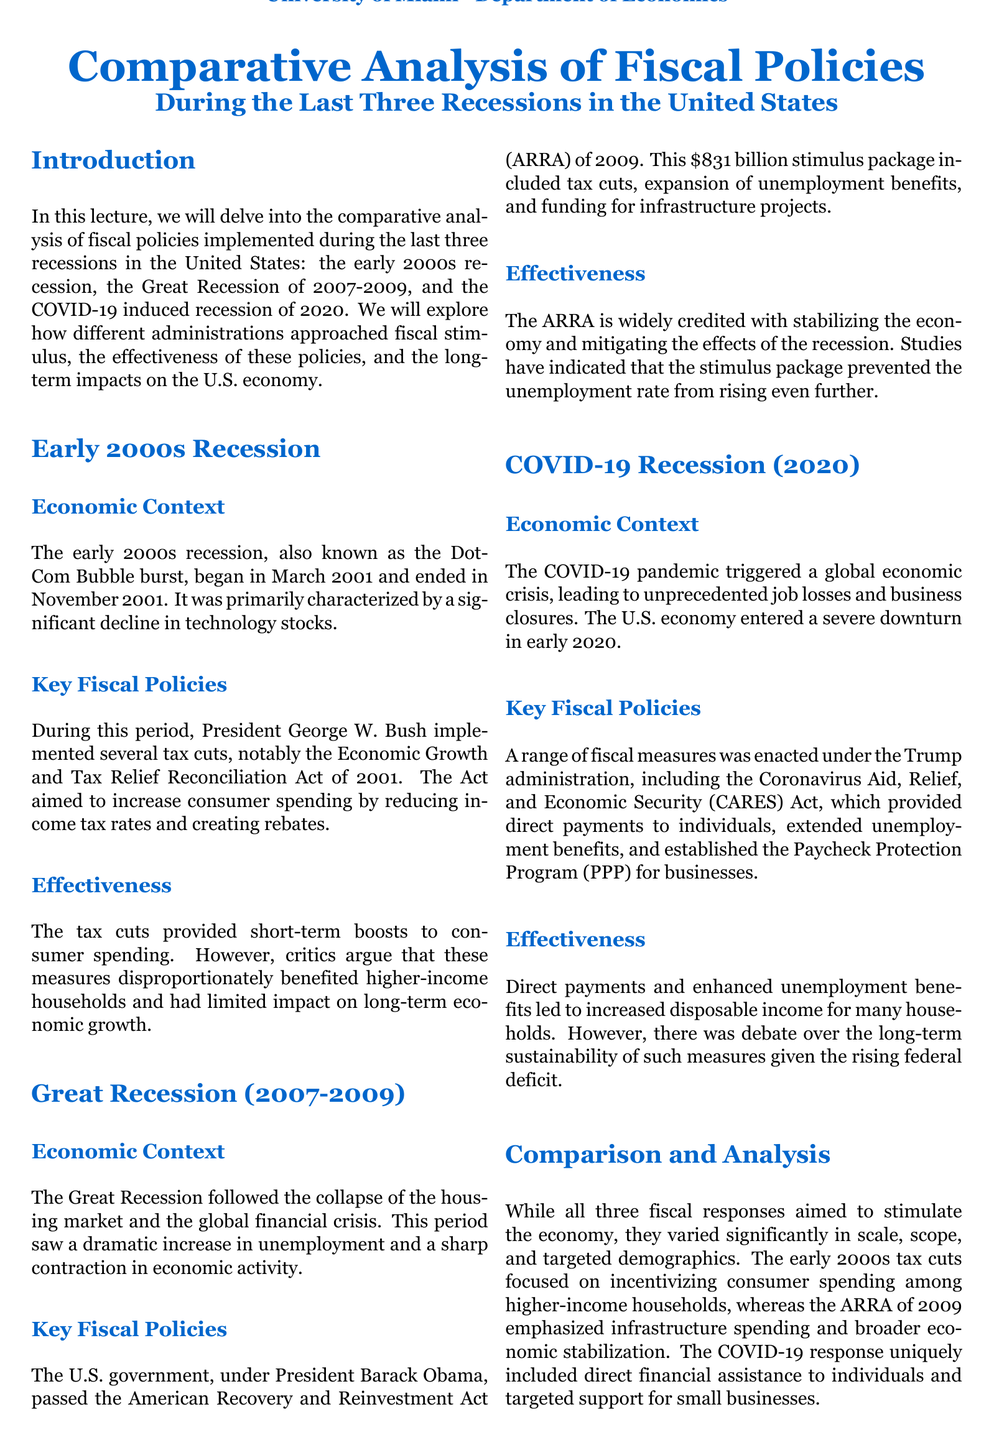what was the date range of the early 2000s recession? The early 2000s recession began in March 2001 and ended in November 2001.
Answer: March 2001 to November 2001 what fiscal policy was implemented during the early 2000s recession? President George W. Bush implemented the Economic Growth and Tax Relief Reconciliation Act of 2001.
Answer: Economic Growth and Tax Relief Reconciliation Act of 2001 how much was the American Recovery and Reinvestment Act (ARRA)? The ARRA was an $831 billion stimulus package passed in 2009.
Answer: $831 billion what administration implemented the Coronavirus Aid, Relief, and Economic Security (CARES) Act? The CARES Act was enacted under the Trump administration.
Answer: Trump administration what was a significant criticism of the early 2000s fiscal policies? Critics argue that the tax cuts disproportionately benefited higher-income households.
Answer: Disproportionately benefited higher-income households which recession emphasized infrastructure spending? The Great Recession's fiscal policy emphasized infrastructure spending through the ARRA.
Answer: Great Recession how did the fiscal response to the COVID-19 recession differ from previous recessions? The COVID-19 response uniquely included direct financial assistance to individuals.
Answer: Direct financial assistance to individuals which recession saw the highest unemployment increase? The Great Recession followed the collapse of the housing market and saw a dramatic increase in unemployment.
Answer: Great Recession what was a primary goal of the fiscal policies during the COVID-19 recession? The policies aimed to provide increased disposable income for many households.
Answer: Increased disposable income for many households 